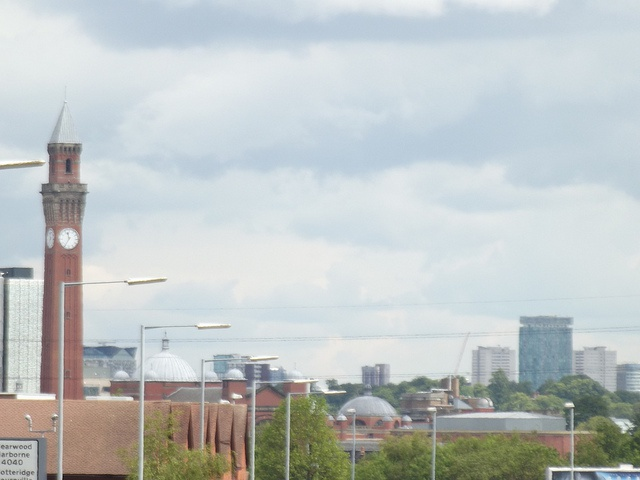Describe the objects in this image and their specific colors. I can see clock in lightgray, darkgray, and gray tones and clock in lightgray, darkgray, and gray tones in this image. 